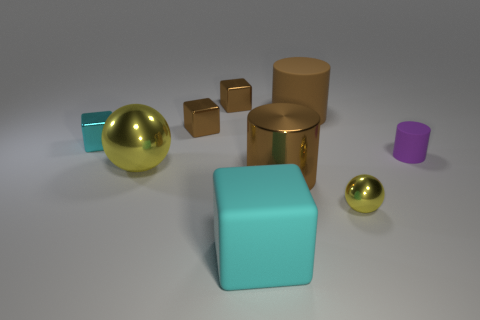What size is the metallic thing that is the same color as the big block?
Give a very brief answer. Small. Is there a rubber thing of the same shape as the big yellow metal object?
Provide a succinct answer. No. The matte cube that is the same size as the brown metallic cylinder is what color?
Keep it short and to the point. Cyan. Is the number of large cyan rubber blocks on the right side of the tiny matte cylinder less than the number of big cyan things to the left of the large yellow shiny sphere?
Your answer should be compact. No. Do the matte cylinder that is to the left of the purple matte object and the cyan matte object have the same size?
Your answer should be very brief. Yes. There is a tiny shiny object that is in front of the small cyan object; what shape is it?
Ensure brevity in your answer.  Sphere. Is the number of brown rubber cylinders greater than the number of big cylinders?
Ensure brevity in your answer.  No. Is the color of the large cylinder that is in front of the tiny rubber cylinder the same as the tiny cylinder?
Your response must be concise. No. How many objects are either cyan blocks behind the big cyan rubber cube or large brown objects in front of the purple thing?
Provide a short and direct response. 2. How many large objects are behind the tiny shiny ball and on the left side of the large brown rubber thing?
Give a very brief answer. 2. 